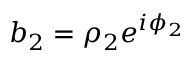Convert formula to latex. <formula><loc_0><loc_0><loc_500><loc_500>b _ { 2 } = \rho _ { 2 } e ^ { i \phi _ { 2 } }</formula> 